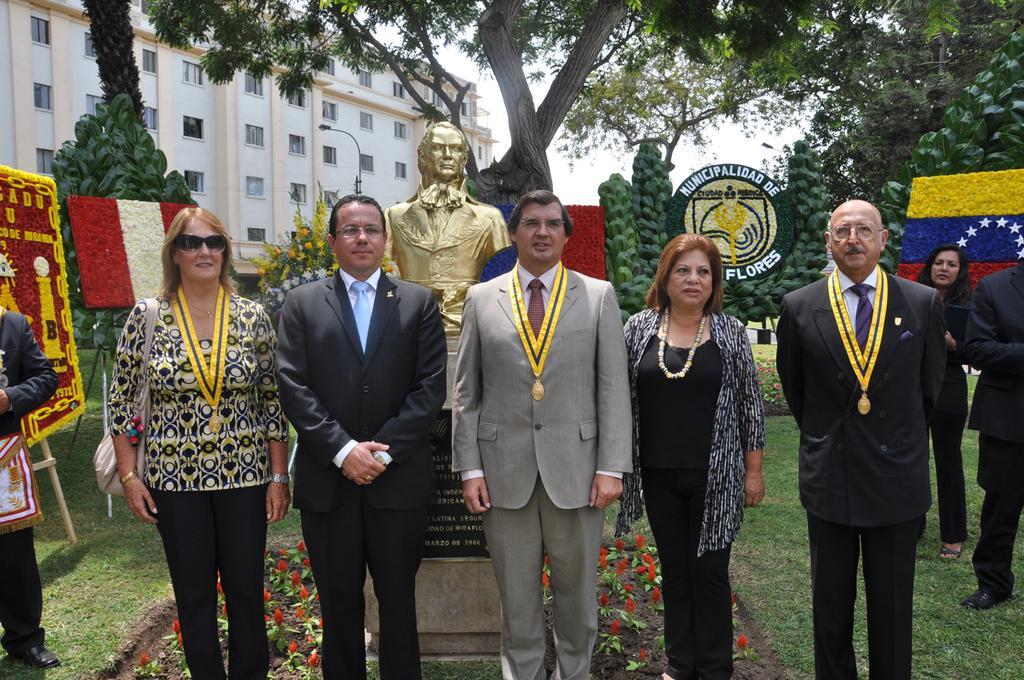Please provide a concise description of this image. In this image I can see a group of people are standing on grass. In the background I can see a memorial, statue, flags, plants, trees, buildings, windows, stand and the sky. This image is taken may be in a park during a day. 